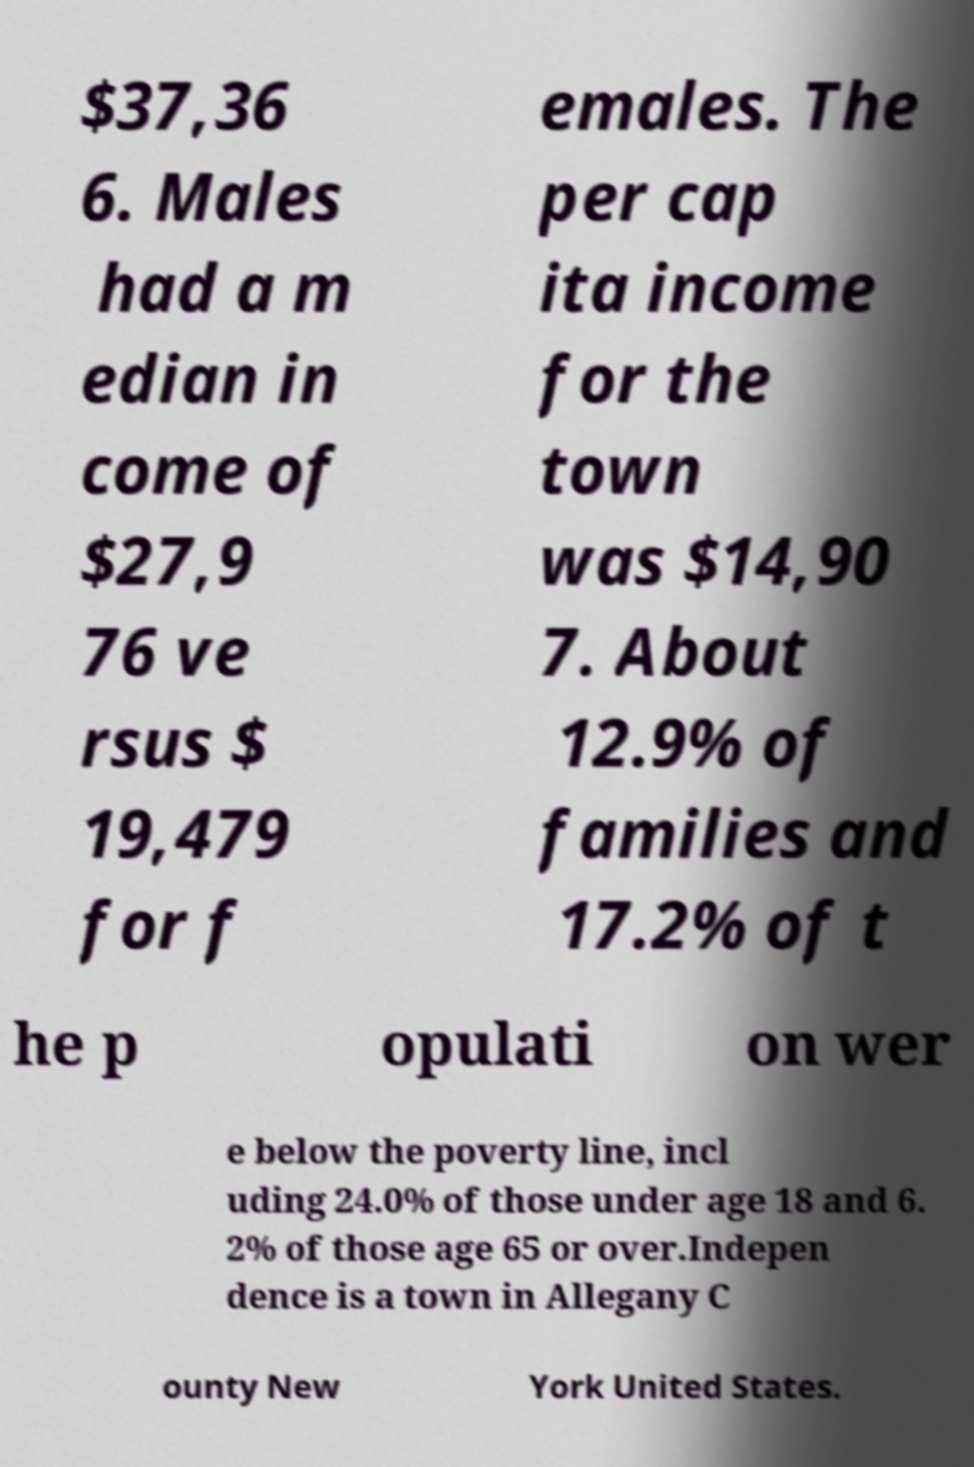Could you extract and type out the text from this image? $37,36 6. Males had a m edian in come of $27,9 76 ve rsus $ 19,479 for f emales. The per cap ita income for the town was $14,90 7. About 12.9% of families and 17.2% of t he p opulati on wer e below the poverty line, incl uding 24.0% of those under age 18 and 6. 2% of those age 65 or over.Indepen dence is a town in Allegany C ounty New York United States. 